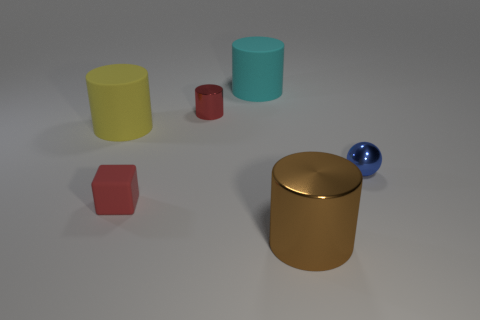There is a object that is in front of the tiny red thing left of the tiny object that is behind the yellow matte cylinder; what is its material?
Provide a succinct answer. Metal. Are there any blocks in front of the metal ball?
Give a very brief answer. Yes. What shape is the shiny object that is the same size as the cyan cylinder?
Offer a terse response. Cylinder. Do the blue object and the red cylinder have the same material?
Your answer should be compact. Yes. What number of rubber objects are either big objects or small blue objects?
Keep it short and to the point. 2. The tiny object that is the same color as the rubber block is what shape?
Offer a terse response. Cylinder. There is a matte object that is in front of the big yellow rubber object; is its color the same as the small cylinder?
Your answer should be compact. Yes. What is the shape of the small metallic object that is on the right side of the large thing in front of the red rubber thing?
Provide a short and direct response. Sphere. What number of objects are either metal cylinders to the left of the large brown thing or large things that are right of the cyan matte cylinder?
Provide a short and direct response. 2. There is a blue object that is the same material as the red cylinder; what shape is it?
Give a very brief answer. Sphere. 